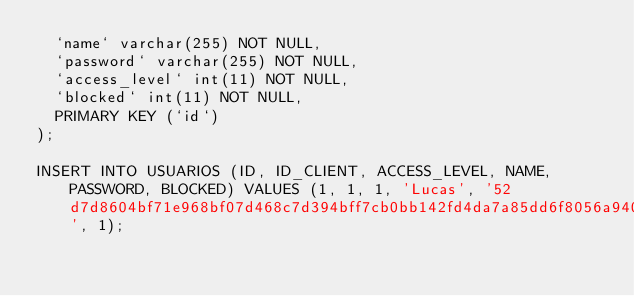<code> <loc_0><loc_0><loc_500><loc_500><_SQL_>  `name` varchar(255) NOT NULL,
  `password` varchar(255) NOT NULL,
  `access_level` int(11) NOT NULL,
  `blocked` int(11) NOT NULL,
  PRIMARY KEY (`id`)
);

INSERT INTO USUARIOS (ID, ID_CLIENT, ACCESS_LEVEL, NAME, PASSWORD, BLOCKED) VALUES (1, 1, 1, 'Lucas', '52d7d8604bf71e968bf07d468c7d394bff7cb0bb142fd4da7a85dd6f8056a940', 1);</code> 